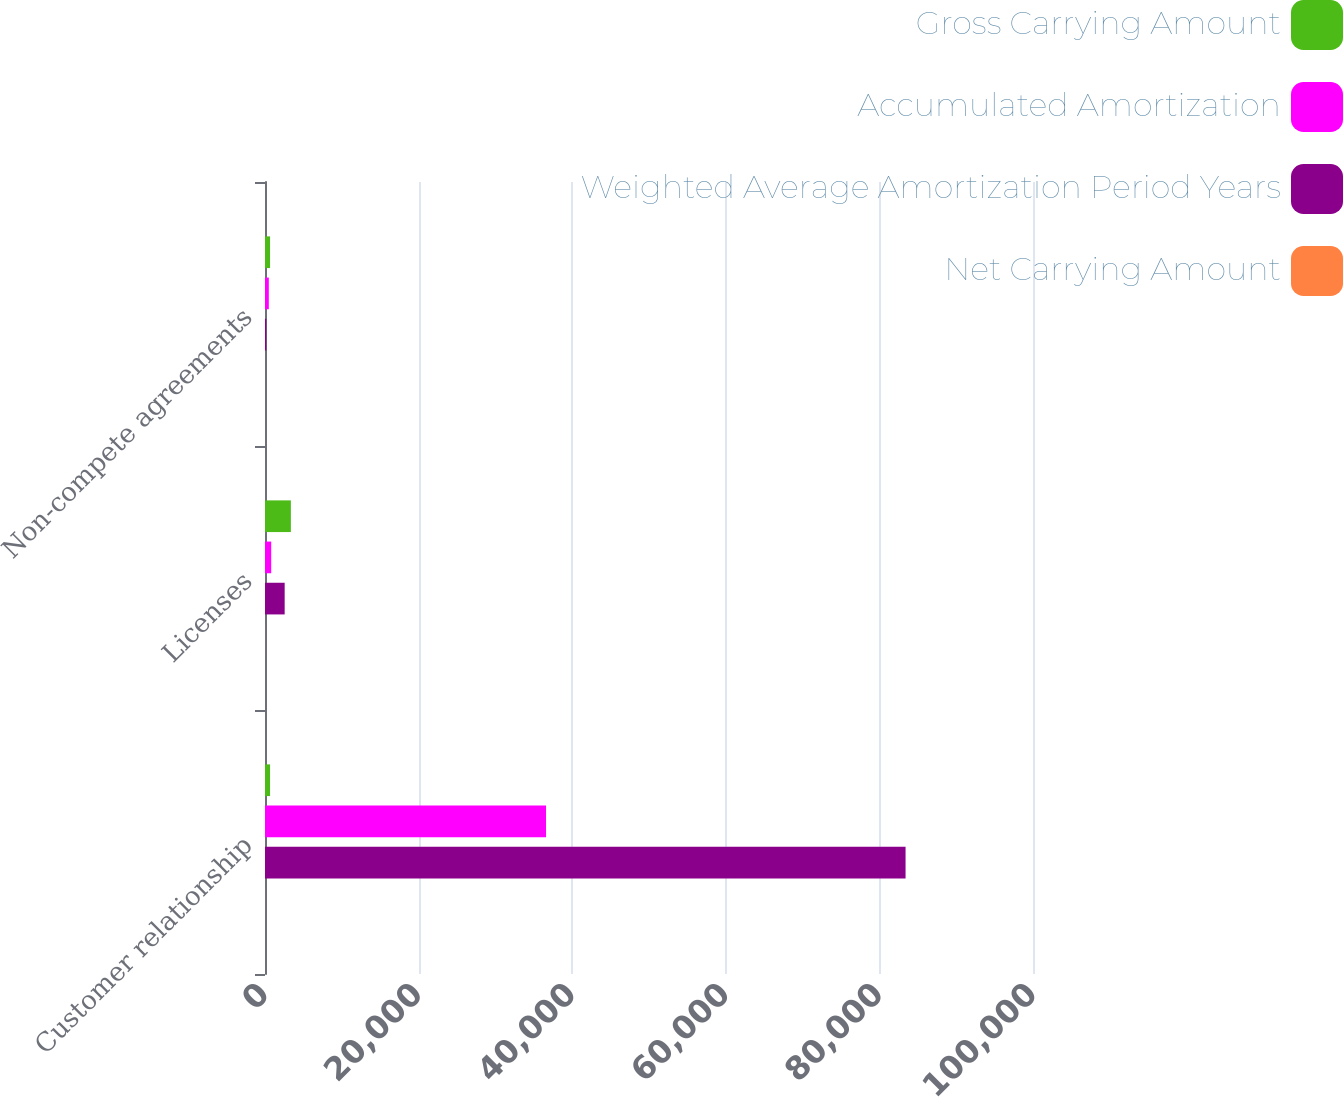Convert chart to OTSL. <chart><loc_0><loc_0><loc_500><loc_500><stacked_bar_chart><ecel><fcel>Customer relationship<fcel>Licenses<fcel>Non-compete agreements<nl><fcel>Gross Carrying Amount<fcel>660<fcel>3368<fcel>660<nl><fcel>Accumulated Amortization<fcel>36593<fcel>807<fcel>495<nl><fcel>Weighted Average Amortization Period Years<fcel>83407<fcel>2561<fcel>165<nl><fcel>Net Carrying Amount<fcel>6<fcel>5.6<fcel>1<nl></chart> 